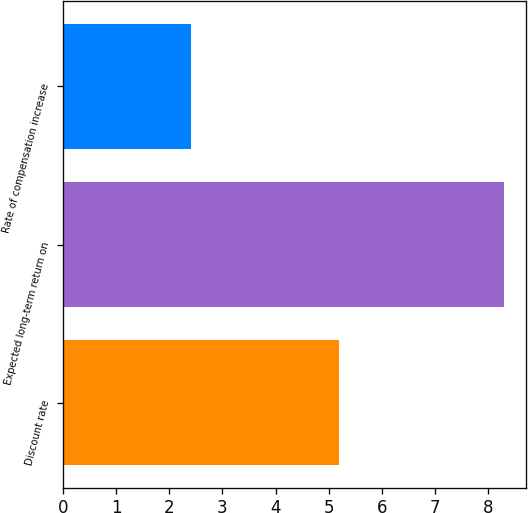Convert chart to OTSL. <chart><loc_0><loc_0><loc_500><loc_500><bar_chart><fcel>Discount rate<fcel>Expected long-term return on<fcel>Rate of compensation increase<nl><fcel>5.2<fcel>8.3<fcel>2.4<nl></chart> 